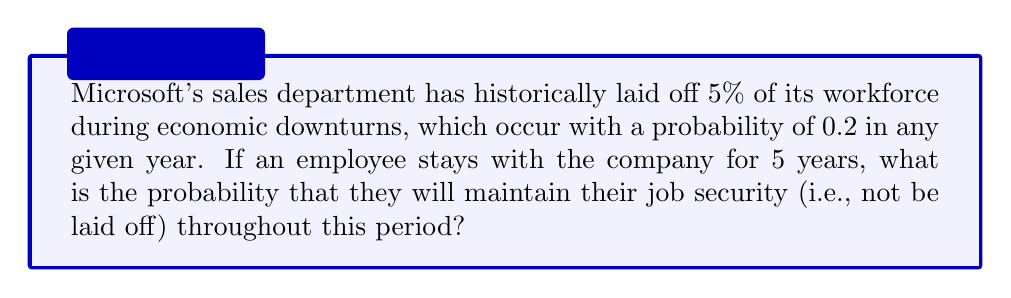Show me your answer to this math problem. Let's approach this step-by-step:

1) First, we need to find the probability of keeping the job in a single year:
   - Probability of an economic downturn: 0.2
   - Probability of being laid off during a downturn: 0.05
   - Probability of being laid off in a given year: $0.2 \times 0.05 = 0.01$
   - Probability of keeping the job in a given year: $1 - 0.01 = 0.99$

2) Now, we need to calculate the probability of keeping the job for all 5 years:
   - This is equivalent to keeping the job in year 1 AND year 2 AND year 3 AND year 4 AND year 5
   - Since these are independent events, we multiply the probabilities:

   $$P(\text{job security for 5 years}) = 0.99^5$$

3) Let's calculate this:
   $$0.99^5 \approx 0.9510$$

4) Convert to a percentage:
   $$0.9510 \times 100\% \approx 95.10\%$$

Thus, the probability of maintaining job security for 5 years is approximately 95.10%.
Answer: $95.10\%$ 